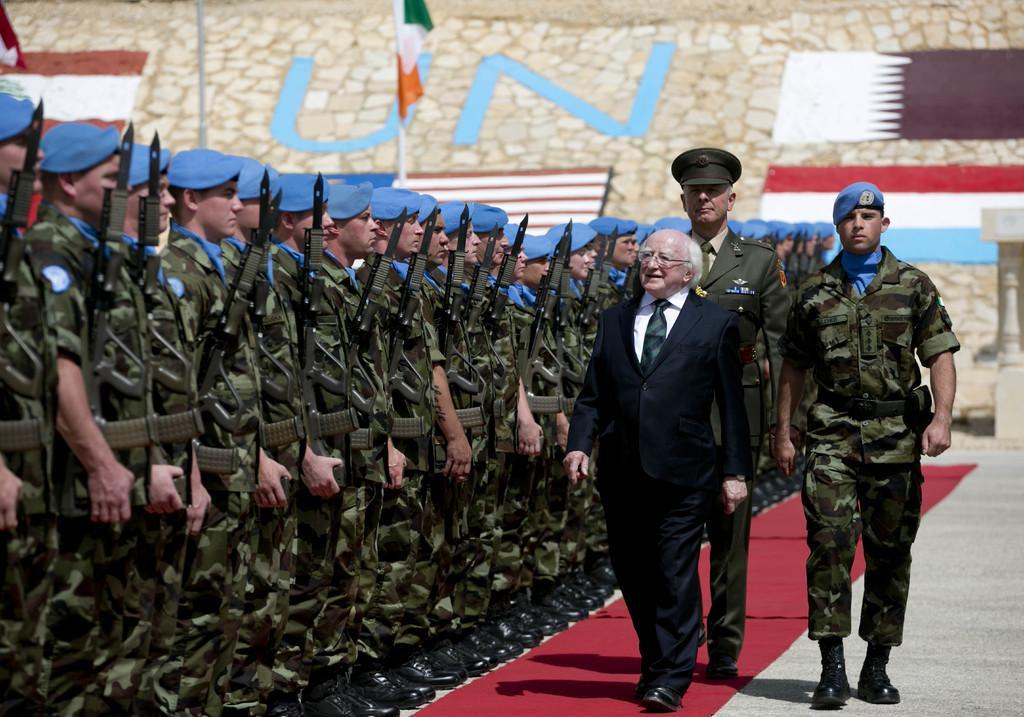Can you describe this image briefly? In the center of the image we can see a man walking. He is wearing a suit, behind him there are two cops walking. On the left we can see people standing in the row. They are wearing uniforms and we can see rifles. In the background there is a flag and a wall. 